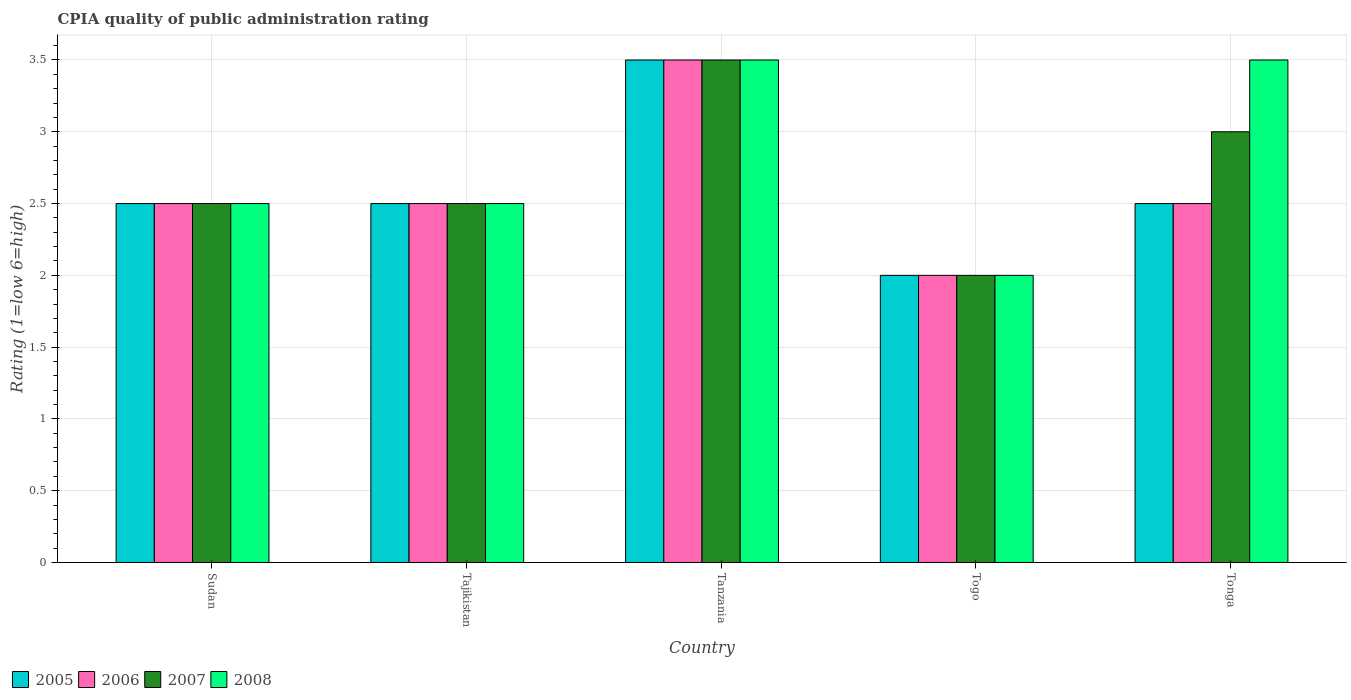How many different coloured bars are there?
Provide a succinct answer. 4. Are the number of bars per tick equal to the number of legend labels?
Ensure brevity in your answer.  Yes. How many bars are there on the 1st tick from the left?
Ensure brevity in your answer.  4. What is the label of the 2nd group of bars from the left?
Offer a terse response. Tajikistan. What is the CPIA rating in 2008 in Tajikistan?
Provide a short and direct response. 2.5. Across all countries, what is the maximum CPIA rating in 2005?
Offer a very short reply. 3.5. In which country was the CPIA rating in 2008 maximum?
Offer a very short reply. Tanzania. In which country was the CPIA rating in 2007 minimum?
Keep it short and to the point. Togo. What is the difference between the CPIA rating in 2005 in Tanzania and the CPIA rating in 2006 in Togo?
Give a very brief answer. 1.5. What is the ratio of the CPIA rating in 2006 in Tajikistan to that in Togo?
Your response must be concise. 1.25. What is the difference between the highest and the second highest CPIA rating in 2006?
Offer a terse response. -1. What is the difference between the highest and the lowest CPIA rating in 2008?
Ensure brevity in your answer.  1.5. What does the 2nd bar from the right in Togo represents?
Your answer should be very brief. 2007. How many bars are there?
Provide a short and direct response. 20. Are all the bars in the graph horizontal?
Provide a short and direct response. No. Are the values on the major ticks of Y-axis written in scientific E-notation?
Make the answer very short. No. Does the graph contain any zero values?
Your answer should be compact. No. Where does the legend appear in the graph?
Your answer should be compact. Bottom left. How are the legend labels stacked?
Give a very brief answer. Horizontal. What is the title of the graph?
Ensure brevity in your answer.  CPIA quality of public administration rating. What is the Rating (1=low 6=high) in 2005 in Sudan?
Provide a succinct answer. 2.5. What is the Rating (1=low 6=high) of 2005 in Tajikistan?
Your answer should be very brief. 2.5. What is the Rating (1=low 6=high) of 2006 in Tanzania?
Make the answer very short. 3.5. What is the Rating (1=low 6=high) of 2007 in Tanzania?
Your response must be concise. 3.5. What is the Rating (1=low 6=high) in 2008 in Tanzania?
Keep it short and to the point. 3.5. What is the Rating (1=low 6=high) of 2005 in Togo?
Make the answer very short. 2. What is the Rating (1=low 6=high) of 2007 in Togo?
Your answer should be very brief. 2. What is the Rating (1=low 6=high) of 2006 in Tonga?
Offer a very short reply. 2.5. What is the Rating (1=low 6=high) of 2007 in Tonga?
Offer a terse response. 3. Across all countries, what is the maximum Rating (1=low 6=high) of 2005?
Provide a short and direct response. 3.5. Across all countries, what is the maximum Rating (1=low 6=high) of 2006?
Provide a succinct answer. 3.5. Across all countries, what is the minimum Rating (1=low 6=high) of 2007?
Ensure brevity in your answer.  2. What is the total Rating (1=low 6=high) in 2005 in the graph?
Offer a terse response. 13. What is the difference between the Rating (1=low 6=high) of 2005 in Sudan and that in Tajikistan?
Provide a succinct answer. 0. What is the difference between the Rating (1=low 6=high) of 2007 in Sudan and that in Tanzania?
Provide a succinct answer. -1. What is the difference between the Rating (1=low 6=high) in 2005 in Sudan and that in Togo?
Offer a very short reply. 0.5. What is the difference between the Rating (1=low 6=high) in 2007 in Sudan and that in Togo?
Offer a very short reply. 0.5. What is the difference between the Rating (1=low 6=high) of 2008 in Sudan and that in Togo?
Make the answer very short. 0.5. What is the difference between the Rating (1=low 6=high) in 2005 in Sudan and that in Tonga?
Give a very brief answer. 0. What is the difference between the Rating (1=low 6=high) in 2008 in Sudan and that in Tonga?
Your answer should be compact. -1. What is the difference between the Rating (1=low 6=high) in 2005 in Tajikistan and that in Tanzania?
Provide a succinct answer. -1. What is the difference between the Rating (1=low 6=high) in 2006 in Tajikistan and that in Tanzania?
Make the answer very short. -1. What is the difference between the Rating (1=low 6=high) in 2007 in Tajikistan and that in Tanzania?
Provide a short and direct response. -1. What is the difference between the Rating (1=low 6=high) of 2008 in Tajikistan and that in Tanzania?
Offer a terse response. -1. What is the difference between the Rating (1=low 6=high) of 2005 in Tajikistan and that in Togo?
Keep it short and to the point. 0.5. What is the difference between the Rating (1=low 6=high) of 2006 in Tajikistan and that in Togo?
Give a very brief answer. 0.5. What is the difference between the Rating (1=low 6=high) in 2007 in Tajikistan and that in Togo?
Your response must be concise. 0.5. What is the difference between the Rating (1=low 6=high) in 2005 in Tajikistan and that in Tonga?
Give a very brief answer. 0. What is the difference between the Rating (1=low 6=high) of 2008 in Tajikistan and that in Tonga?
Provide a short and direct response. -1. What is the difference between the Rating (1=low 6=high) of 2005 in Tanzania and that in Togo?
Offer a very short reply. 1.5. What is the difference between the Rating (1=low 6=high) in 2006 in Tanzania and that in Togo?
Make the answer very short. 1.5. What is the difference between the Rating (1=low 6=high) of 2007 in Tanzania and that in Togo?
Ensure brevity in your answer.  1.5. What is the difference between the Rating (1=low 6=high) in 2008 in Tanzania and that in Togo?
Your answer should be very brief. 1.5. What is the difference between the Rating (1=low 6=high) in 2005 in Tanzania and that in Tonga?
Provide a succinct answer. 1. What is the difference between the Rating (1=low 6=high) in 2006 in Tanzania and that in Tonga?
Give a very brief answer. 1. What is the difference between the Rating (1=low 6=high) in 2007 in Tanzania and that in Tonga?
Offer a terse response. 0.5. What is the difference between the Rating (1=low 6=high) of 2005 in Sudan and the Rating (1=low 6=high) of 2006 in Tajikistan?
Keep it short and to the point. 0. What is the difference between the Rating (1=low 6=high) of 2005 in Sudan and the Rating (1=low 6=high) of 2008 in Tajikistan?
Your response must be concise. 0. What is the difference between the Rating (1=low 6=high) in 2006 in Sudan and the Rating (1=low 6=high) in 2007 in Tajikistan?
Make the answer very short. 0. What is the difference between the Rating (1=low 6=high) in 2005 in Sudan and the Rating (1=low 6=high) in 2006 in Tanzania?
Make the answer very short. -1. What is the difference between the Rating (1=low 6=high) of 2005 in Sudan and the Rating (1=low 6=high) of 2007 in Tanzania?
Keep it short and to the point. -1. What is the difference between the Rating (1=low 6=high) of 2006 in Sudan and the Rating (1=low 6=high) of 2008 in Tanzania?
Provide a succinct answer. -1. What is the difference between the Rating (1=low 6=high) in 2007 in Sudan and the Rating (1=low 6=high) in 2008 in Tanzania?
Provide a succinct answer. -1. What is the difference between the Rating (1=low 6=high) of 2005 in Sudan and the Rating (1=low 6=high) of 2007 in Togo?
Provide a short and direct response. 0.5. What is the difference between the Rating (1=low 6=high) of 2005 in Sudan and the Rating (1=low 6=high) of 2008 in Togo?
Offer a very short reply. 0.5. What is the difference between the Rating (1=low 6=high) of 2006 in Sudan and the Rating (1=low 6=high) of 2007 in Togo?
Your answer should be very brief. 0.5. What is the difference between the Rating (1=low 6=high) in 2007 in Sudan and the Rating (1=low 6=high) in 2008 in Togo?
Your answer should be very brief. 0.5. What is the difference between the Rating (1=low 6=high) in 2005 in Sudan and the Rating (1=low 6=high) in 2006 in Tonga?
Ensure brevity in your answer.  0. What is the difference between the Rating (1=low 6=high) in 2005 in Sudan and the Rating (1=low 6=high) in 2008 in Tonga?
Offer a terse response. -1. What is the difference between the Rating (1=low 6=high) in 2006 in Sudan and the Rating (1=low 6=high) in 2007 in Tonga?
Your answer should be very brief. -0.5. What is the difference between the Rating (1=low 6=high) of 2007 in Sudan and the Rating (1=low 6=high) of 2008 in Tonga?
Your answer should be very brief. -1. What is the difference between the Rating (1=low 6=high) of 2005 in Tajikistan and the Rating (1=low 6=high) of 2007 in Tanzania?
Your answer should be very brief. -1. What is the difference between the Rating (1=low 6=high) of 2006 in Tajikistan and the Rating (1=low 6=high) of 2007 in Tanzania?
Offer a very short reply. -1. What is the difference between the Rating (1=low 6=high) of 2006 in Tajikistan and the Rating (1=low 6=high) of 2008 in Tanzania?
Provide a short and direct response. -1. What is the difference between the Rating (1=low 6=high) in 2005 in Tajikistan and the Rating (1=low 6=high) in 2006 in Togo?
Your answer should be very brief. 0.5. What is the difference between the Rating (1=low 6=high) of 2005 in Tajikistan and the Rating (1=low 6=high) of 2007 in Togo?
Give a very brief answer. 0.5. What is the difference between the Rating (1=low 6=high) of 2006 in Tajikistan and the Rating (1=low 6=high) of 2008 in Togo?
Offer a terse response. 0.5. What is the difference between the Rating (1=low 6=high) in 2007 in Tajikistan and the Rating (1=low 6=high) in 2008 in Togo?
Make the answer very short. 0.5. What is the difference between the Rating (1=low 6=high) of 2005 in Tajikistan and the Rating (1=low 6=high) of 2006 in Tonga?
Provide a short and direct response. 0. What is the difference between the Rating (1=low 6=high) in 2005 in Tajikistan and the Rating (1=low 6=high) in 2008 in Tonga?
Give a very brief answer. -1. What is the difference between the Rating (1=low 6=high) of 2006 in Tajikistan and the Rating (1=low 6=high) of 2007 in Tonga?
Provide a short and direct response. -0.5. What is the difference between the Rating (1=low 6=high) of 2006 in Tajikistan and the Rating (1=low 6=high) of 2008 in Tonga?
Your answer should be very brief. -1. What is the difference between the Rating (1=low 6=high) of 2005 in Tanzania and the Rating (1=low 6=high) of 2006 in Togo?
Provide a succinct answer. 1.5. What is the difference between the Rating (1=low 6=high) in 2005 in Tanzania and the Rating (1=low 6=high) in 2008 in Togo?
Provide a short and direct response. 1.5. What is the difference between the Rating (1=low 6=high) of 2006 in Tanzania and the Rating (1=low 6=high) of 2007 in Togo?
Provide a short and direct response. 1.5. What is the difference between the Rating (1=low 6=high) in 2006 in Tanzania and the Rating (1=low 6=high) in 2008 in Tonga?
Offer a terse response. 0. What is the difference between the Rating (1=low 6=high) in 2007 in Tanzania and the Rating (1=low 6=high) in 2008 in Tonga?
Ensure brevity in your answer.  0. What is the difference between the Rating (1=low 6=high) of 2006 in Togo and the Rating (1=low 6=high) of 2007 in Tonga?
Give a very brief answer. -1. What is the difference between the Rating (1=low 6=high) of 2006 in Togo and the Rating (1=low 6=high) of 2008 in Tonga?
Ensure brevity in your answer.  -1.5. What is the difference between the Rating (1=low 6=high) of 2005 and Rating (1=low 6=high) of 2008 in Sudan?
Make the answer very short. 0. What is the difference between the Rating (1=low 6=high) in 2006 and Rating (1=low 6=high) in 2007 in Sudan?
Ensure brevity in your answer.  0. What is the difference between the Rating (1=low 6=high) in 2006 and Rating (1=low 6=high) in 2008 in Sudan?
Offer a terse response. 0. What is the difference between the Rating (1=low 6=high) of 2005 and Rating (1=low 6=high) of 2006 in Tajikistan?
Give a very brief answer. 0. What is the difference between the Rating (1=low 6=high) of 2005 and Rating (1=low 6=high) of 2007 in Tajikistan?
Make the answer very short. 0. What is the difference between the Rating (1=low 6=high) of 2007 and Rating (1=low 6=high) of 2008 in Tajikistan?
Provide a succinct answer. 0. What is the difference between the Rating (1=low 6=high) in 2005 and Rating (1=low 6=high) in 2007 in Tanzania?
Ensure brevity in your answer.  0. What is the difference between the Rating (1=low 6=high) in 2005 and Rating (1=low 6=high) in 2008 in Togo?
Provide a succinct answer. 0. What is the difference between the Rating (1=low 6=high) of 2006 and Rating (1=low 6=high) of 2008 in Togo?
Provide a short and direct response. 0. What is the difference between the Rating (1=low 6=high) in 2007 and Rating (1=low 6=high) in 2008 in Togo?
Your response must be concise. 0. What is the difference between the Rating (1=low 6=high) of 2005 and Rating (1=low 6=high) of 2006 in Tonga?
Provide a short and direct response. 0. What is the difference between the Rating (1=low 6=high) in 2005 and Rating (1=low 6=high) in 2007 in Tonga?
Your answer should be compact. -0.5. What is the difference between the Rating (1=low 6=high) of 2005 and Rating (1=low 6=high) of 2008 in Tonga?
Your response must be concise. -1. What is the ratio of the Rating (1=low 6=high) of 2005 in Sudan to that in Tajikistan?
Provide a short and direct response. 1. What is the ratio of the Rating (1=low 6=high) of 2006 in Sudan to that in Tajikistan?
Offer a terse response. 1. What is the ratio of the Rating (1=low 6=high) of 2008 in Sudan to that in Tajikistan?
Offer a terse response. 1. What is the ratio of the Rating (1=low 6=high) in 2005 in Sudan to that in Tanzania?
Your answer should be very brief. 0.71. What is the ratio of the Rating (1=low 6=high) in 2007 in Sudan to that in Tanzania?
Ensure brevity in your answer.  0.71. What is the ratio of the Rating (1=low 6=high) in 2005 in Sudan to that in Togo?
Offer a terse response. 1.25. What is the ratio of the Rating (1=low 6=high) in 2006 in Sudan to that in Togo?
Provide a succinct answer. 1.25. What is the ratio of the Rating (1=low 6=high) in 2007 in Sudan to that in Togo?
Ensure brevity in your answer.  1.25. What is the ratio of the Rating (1=low 6=high) in 2007 in Sudan to that in Tonga?
Your answer should be very brief. 0.83. What is the ratio of the Rating (1=low 6=high) of 2005 in Tajikistan to that in Tanzania?
Ensure brevity in your answer.  0.71. What is the ratio of the Rating (1=low 6=high) in 2006 in Tajikistan to that in Tanzania?
Offer a very short reply. 0.71. What is the ratio of the Rating (1=low 6=high) in 2008 in Tajikistan to that in Tanzania?
Provide a succinct answer. 0.71. What is the ratio of the Rating (1=low 6=high) in 2007 in Tajikistan to that in Togo?
Your answer should be very brief. 1.25. What is the ratio of the Rating (1=low 6=high) in 2005 in Tajikistan to that in Tonga?
Offer a very short reply. 1. What is the ratio of the Rating (1=low 6=high) of 2007 in Tajikistan to that in Tonga?
Give a very brief answer. 0.83. What is the ratio of the Rating (1=low 6=high) of 2008 in Tanzania to that in Togo?
Provide a succinct answer. 1.75. What is the ratio of the Rating (1=low 6=high) of 2005 in Tanzania to that in Tonga?
Provide a succinct answer. 1.4. What is the ratio of the Rating (1=low 6=high) of 2006 in Tanzania to that in Tonga?
Keep it short and to the point. 1.4. What is the ratio of the Rating (1=low 6=high) of 2008 in Tanzania to that in Tonga?
Keep it short and to the point. 1. What is the ratio of the Rating (1=low 6=high) in 2005 in Togo to that in Tonga?
Ensure brevity in your answer.  0.8. What is the ratio of the Rating (1=low 6=high) of 2006 in Togo to that in Tonga?
Provide a short and direct response. 0.8. What is the difference between the highest and the lowest Rating (1=low 6=high) of 2005?
Offer a very short reply. 1.5. What is the difference between the highest and the lowest Rating (1=low 6=high) of 2008?
Give a very brief answer. 1.5. 